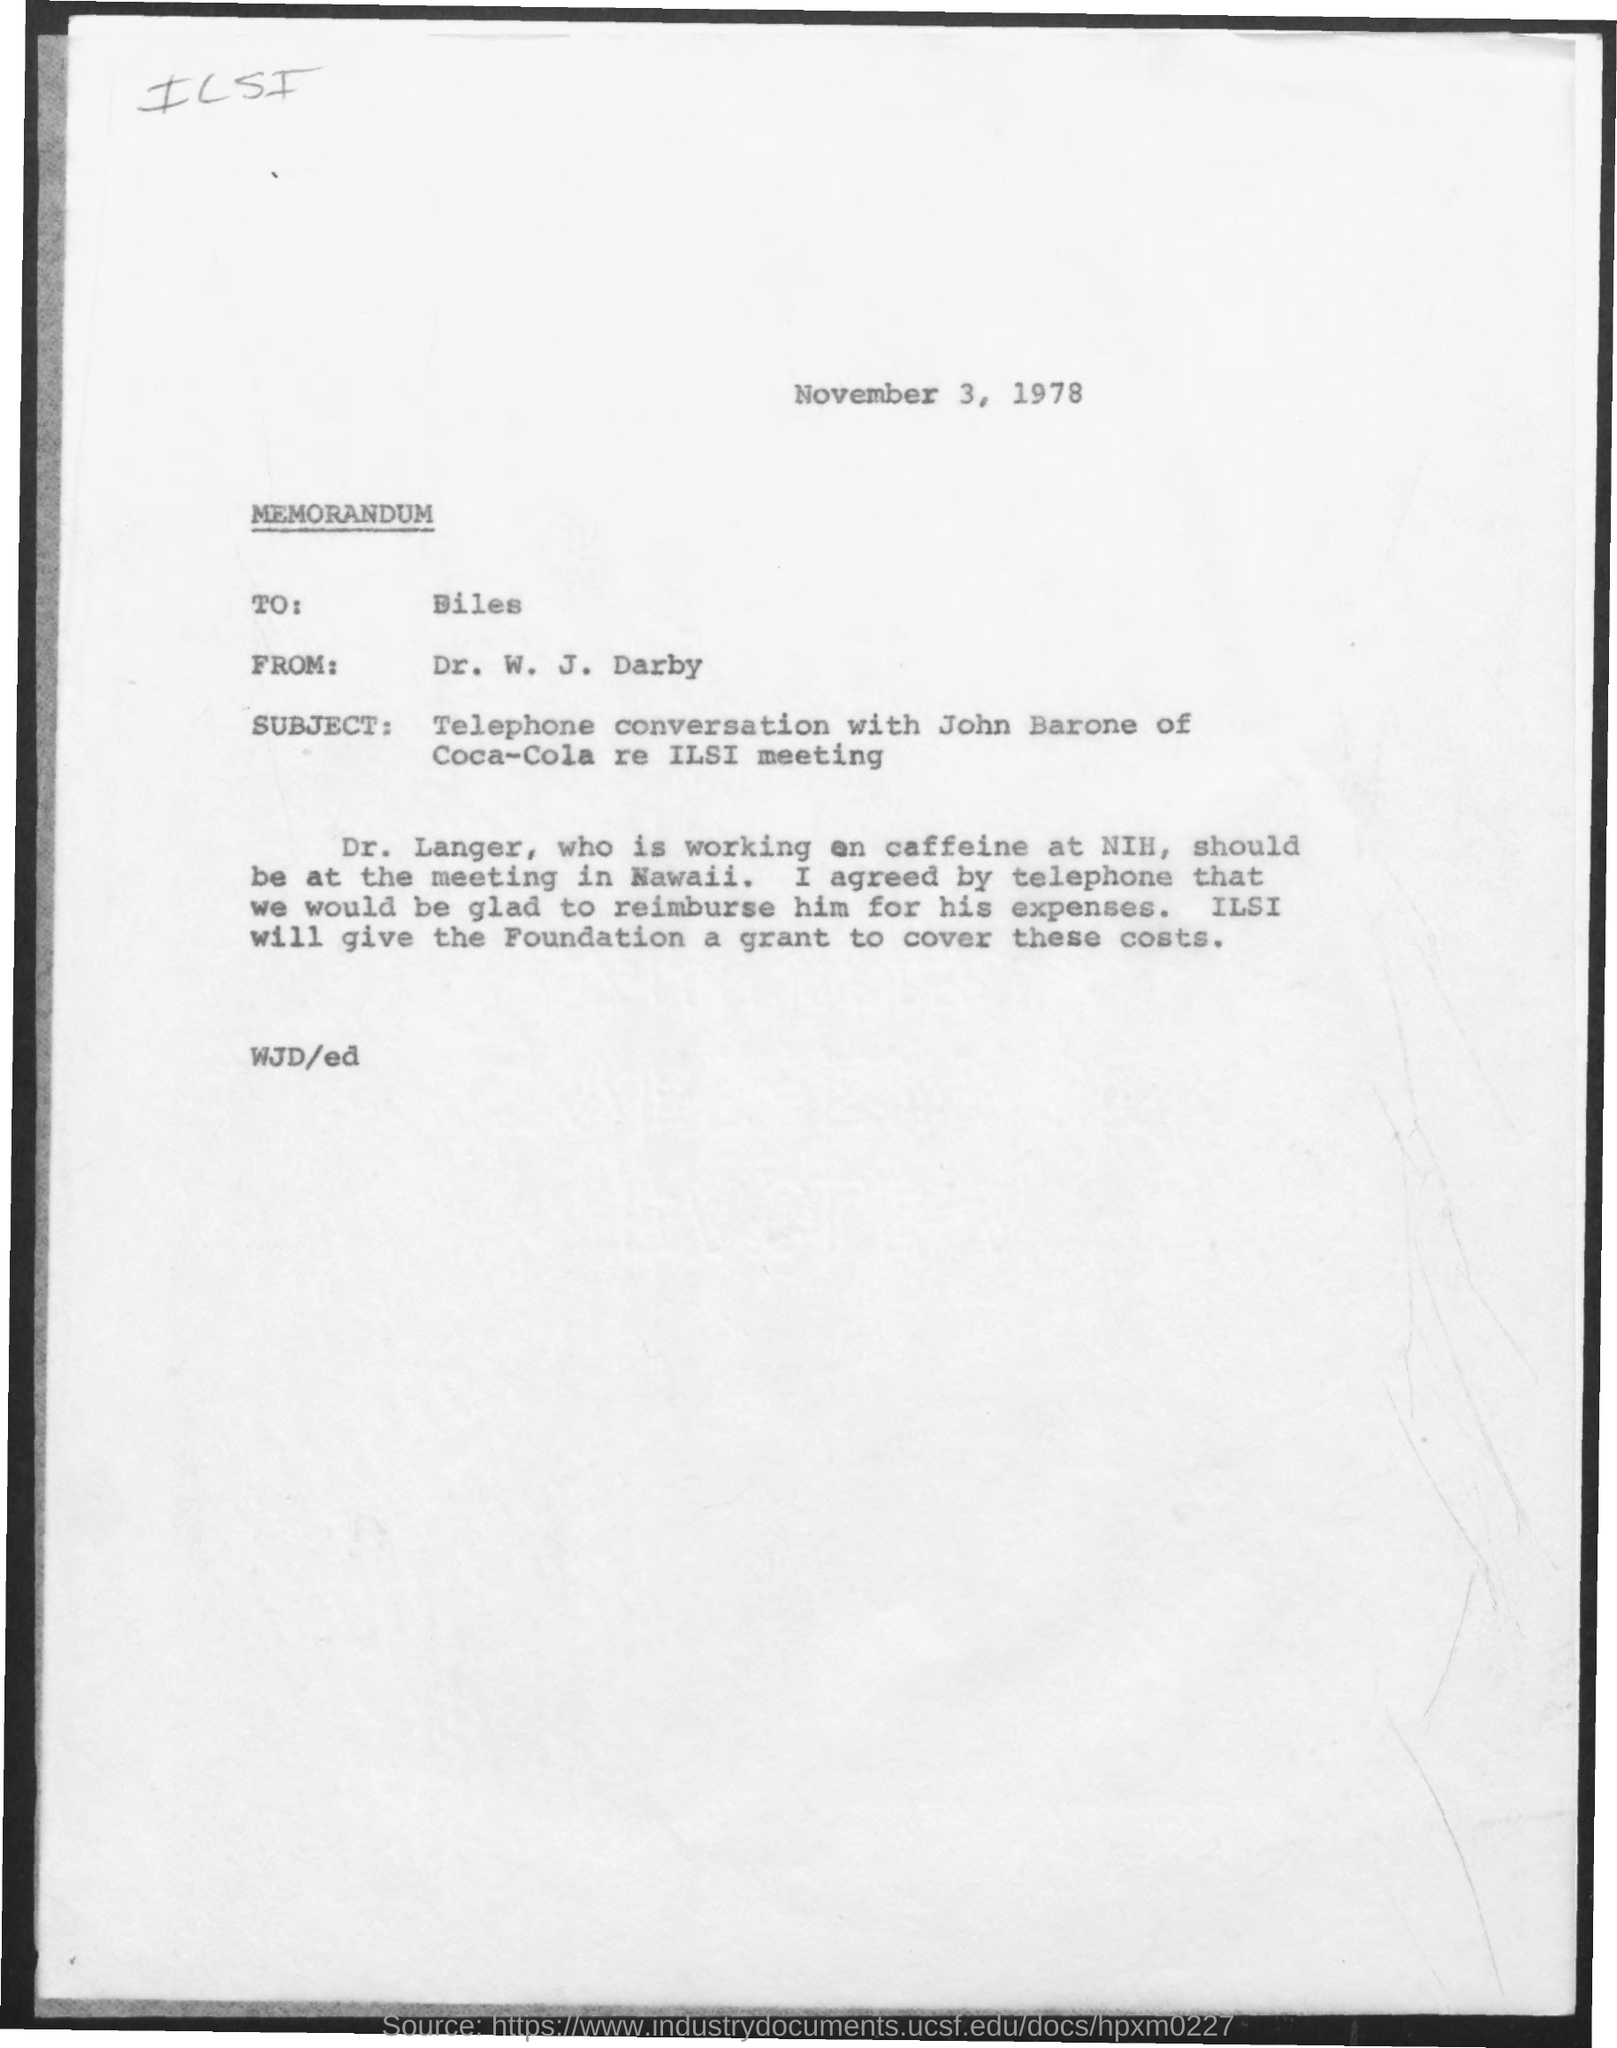Memorandum is addressed to which person?
Give a very brief answer. Biles. 